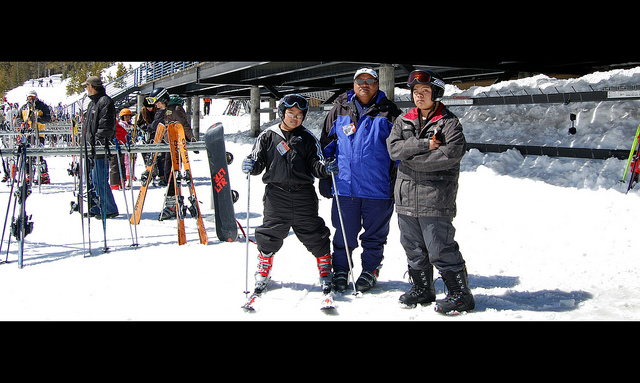How many of the three people are wearing skis? In the image, only one person out of the three visible is wearing skis. You can see him positioned on the left with the skis visibly strapped to his boots, ready for a thrilling run down the slopes. 